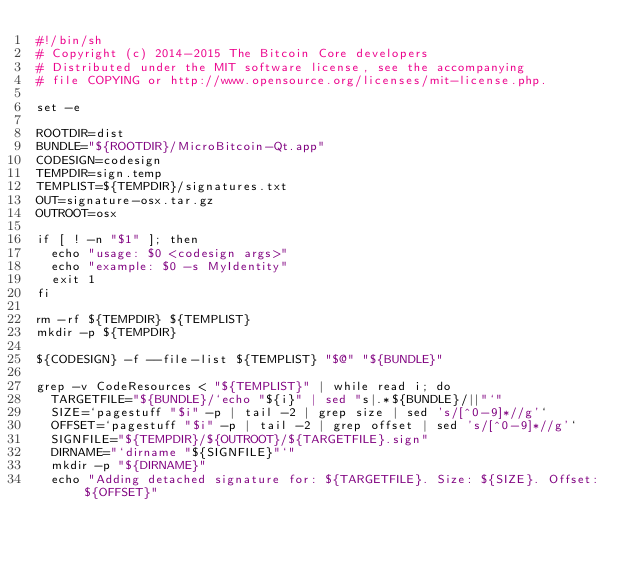<code> <loc_0><loc_0><loc_500><loc_500><_Bash_>#!/bin/sh
# Copyright (c) 2014-2015 The Bitcoin Core developers
# Distributed under the MIT software license, see the accompanying
# file COPYING or http://www.opensource.org/licenses/mit-license.php.

set -e

ROOTDIR=dist
BUNDLE="${ROOTDIR}/MicroBitcoin-Qt.app"
CODESIGN=codesign
TEMPDIR=sign.temp
TEMPLIST=${TEMPDIR}/signatures.txt
OUT=signature-osx.tar.gz
OUTROOT=osx

if [ ! -n "$1" ]; then
  echo "usage: $0 <codesign args>"
  echo "example: $0 -s MyIdentity"
  exit 1
fi

rm -rf ${TEMPDIR} ${TEMPLIST}
mkdir -p ${TEMPDIR}

${CODESIGN} -f --file-list ${TEMPLIST} "$@" "${BUNDLE}"

grep -v CodeResources < "${TEMPLIST}" | while read i; do
  TARGETFILE="${BUNDLE}/`echo "${i}" | sed "s|.*${BUNDLE}/||"`"
  SIZE=`pagestuff "$i" -p | tail -2 | grep size | sed 's/[^0-9]*//g'`
  OFFSET=`pagestuff "$i" -p | tail -2 | grep offset | sed 's/[^0-9]*//g'`
  SIGNFILE="${TEMPDIR}/${OUTROOT}/${TARGETFILE}.sign"
  DIRNAME="`dirname "${SIGNFILE}"`"
  mkdir -p "${DIRNAME}"
  echo "Adding detached signature for: ${TARGETFILE}. Size: ${SIZE}. Offset: ${OFFSET}"</code> 